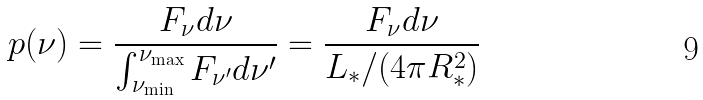Convert formula to latex. <formula><loc_0><loc_0><loc_500><loc_500>p ( \nu ) = \frac { F _ { \nu } d \nu } { \int _ { \nu _ { \min } } ^ { \nu _ { \max } } F _ { \nu ^ { \prime } } d \nu ^ { \prime } } = \frac { F _ { \nu } d \nu } { L _ { * } / ( 4 \pi R ^ { 2 } _ { * } ) }</formula> 